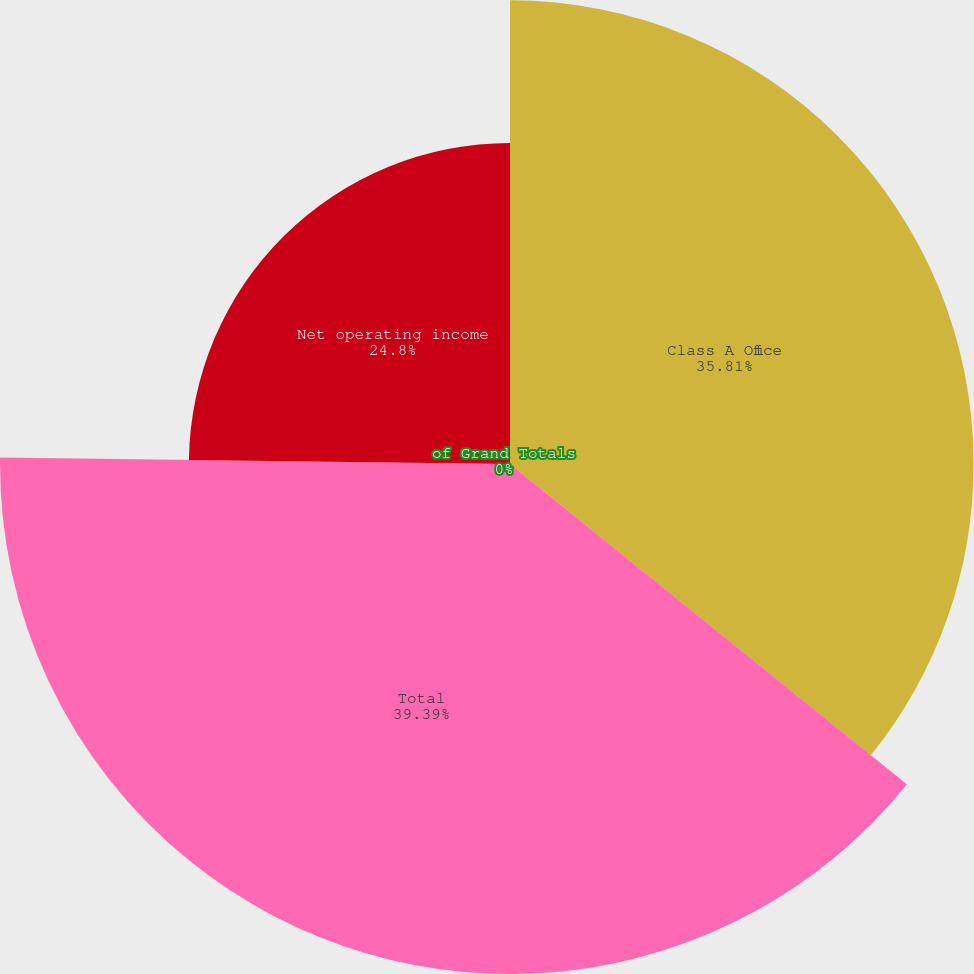Convert chart to OTSL. <chart><loc_0><loc_0><loc_500><loc_500><pie_chart><fcel>Class A Office<fcel>Total<fcel>of Grand Totals<fcel>Net operating income<nl><fcel>35.81%<fcel>39.39%<fcel>0.0%<fcel>24.8%<nl></chart> 